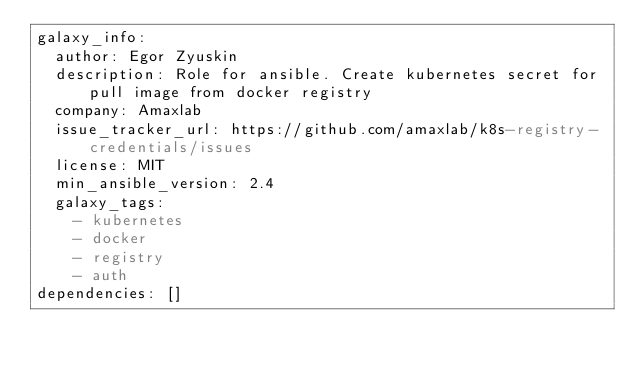Convert code to text. <code><loc_0><loc_0><loc_500><loc_500><_YAML_>galaxy_info:
  author: Egor Zyuskin
  description: Role for ansible. Create kubernetes secret for pull image from docker registry
  company: Amaxlab
  issue_tracker_url: https://github.com/amaxlab/k8s-registry-credentials/issues
  license: MIT
  min_ansible_version: 2.4
  galaxy_tags:
    - kubernetes
    - docker
    - registry
    - auth
dependencies: []
</code> 